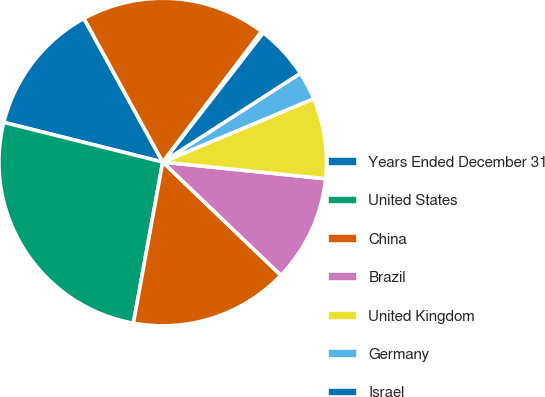<chart> <loc_0><loc_0><loc_500><loc_500><pie_chart><fcel>Years Ended December 31<fcel>United States<fcel>China<fcel>Brazil<fcel>United Kingdom<fcel>Germany<fcel>Israel<fcel>Singapore<fcel>Other nations net of<nl><fcel>13.12%<fcel>26.03%<fcel>15.7%<fcel>10.54%<fcel>7.95%<fcel>2.79%<fcel>5.37%<fcel>0.21%<fcel>18.29%<nl></chart> 